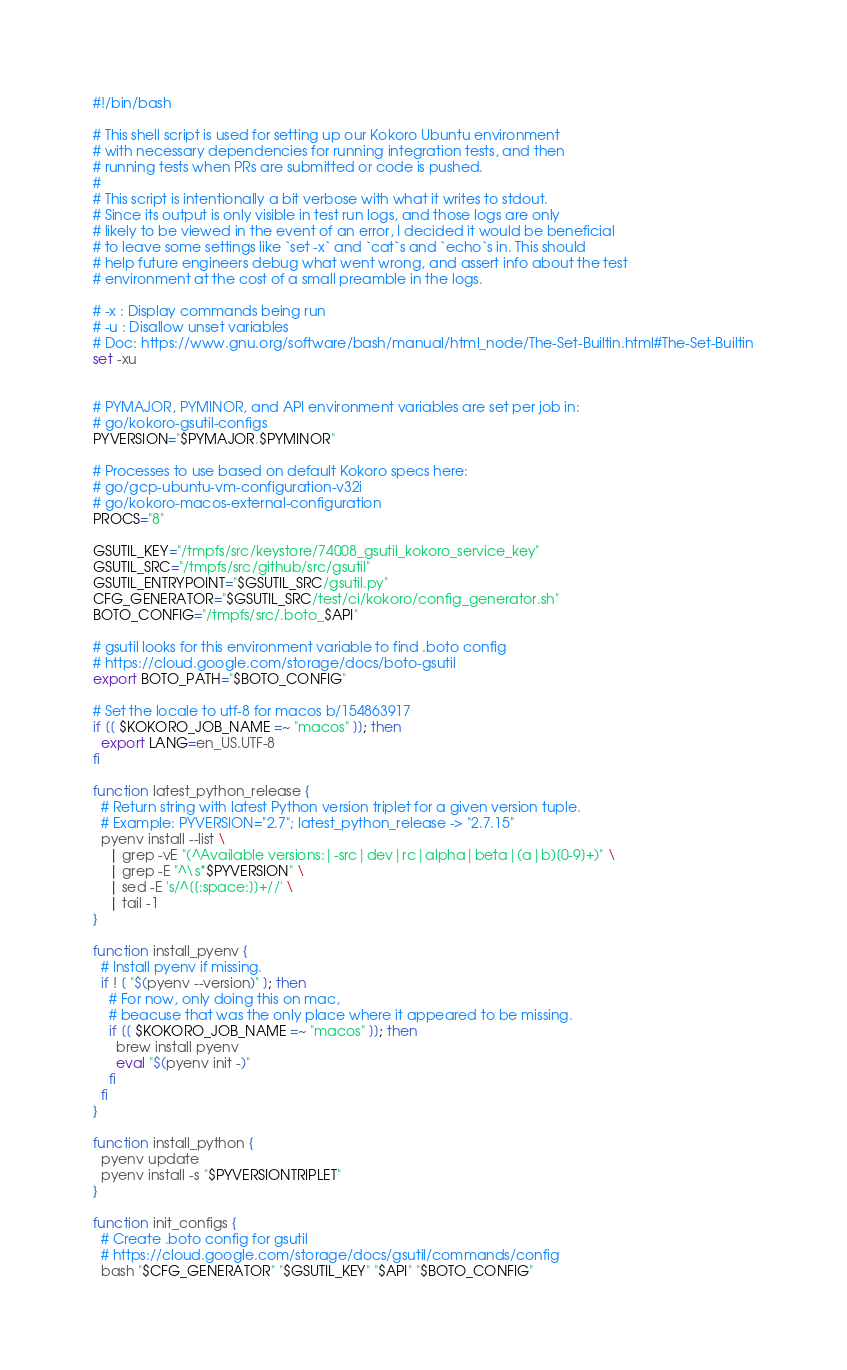<code> <loc_0><loc_0><loc_500><loc_500><_Bash_>#!/bin/bash

# This shell script is used for setting up our Kokoro Ubuntu environment
# with necessary dependencies for running integration tests, and then
# running tests when PRs are submitted or code is pushed.
#
# This script is intentionally a bit verbose with what it writes to stdout.
# Since its output is only visible in test run logs, and those logs are only
# likely to be viewed in the event of an error, I decided it would be beneficial
# to leave some settings like `set -x` and `cat`s and `echo`s in. This should
# help future engineers debug what went wrong, and assert info about the test
# environment at the cost of a small preamble in the logs.

# -x : Display commands being run
# -u : Disallow unset variables
# Doc: https://www.gnu.org/software/bash/manual/html_node/The-Set-Builtin.html#The-Set-Builtin
set -xu


# PYMAJOR, PYMINOR, and API environment variables are set per job in:
# go/kokoro-gsutil-configs
PYVERSION="$PYMAJOR.$PYMINOR"

# Processes to use based on default Kokoro specs here:
# go/gcp-ubuntu-vm-configuration-v32i
# go/kokoro-macos-external-configuration
PROCS="8"

GSUTIL_KEY="/tmpfs/src/keystore/74008_gsutil_kokoro_service_key"
GSUTIL_SRC="/tmpfs/src/github/src/gsutil"
GSUTIL_ENTRYPOINT="$GSUTIL_SRC/gsutil.py"
CFG_GENERATOR="$GSUTIL_SRC/test/ci/kokoro/config_generator.sh"
BOTO_CONFIG="/tmpfs/src/.boto_$API"

# gsutil looks for this environment variable to find .boto config
# https://cloud.google.com/storage/docs/boto-gsutil
export BOTO_PATH="$BOTO_CONFIG"

# Set the locale to utf-8 for macos b/154863917
if [[ $KOKORO_JOB_NAME =~ "macos" ]]; then
  export LANG=en_US.UTF-8
fi

function latest_python_release {
  # Return string with latest Python version triplet for a given version tuple.
  # Example: PYVERSION="2.7"; latest_python_release -> "2.7.15"
  pyenv install --list \
    | grep -vE "(^Available versions:|-src|dev|rc|alpha|beta|(a|b)[0-9]+)" \
    | grep -E "^\s*$PYVERSION" \
    | sed -E 's/^[[:space:]]+//' \
    | tail -1
}

function install_pyenv {
  # Install pyenv if missing.
  if ! [ "$(pyenv --version)" ]; then
    # For now, only doing this on mac,
    # beacuse that was the only place where it appeared to be missing.
    if [[ $KOKORO_JOB_NAME =~ "macos" ]]; then
      brew install pyenv
      eval "$(pyenv init -)"
    fi
  fi
}

function install_python {
  pyenv update
  pyenv install -s "$PYVERSIONTRIPLET"
}

function init_configs {
  # Create .boto config for gsutil
  # https://cloud.google.com/storage/docs/gsutil/commands/config
  bash "$CFG_GENERATOR" "$GSUTIL_KEY" "$API" "$BOTO_CONFIG"</code> 